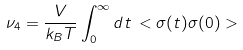<formula> <loc_0><loc_0><loc_500><loc_500>\nu _ { 4 } = \frac { V } { k _ { B } T } \int _ { 0 } ^ { \infty } d t \, < \sigma ( t ) \sigma ( 0 ) ></formula> 